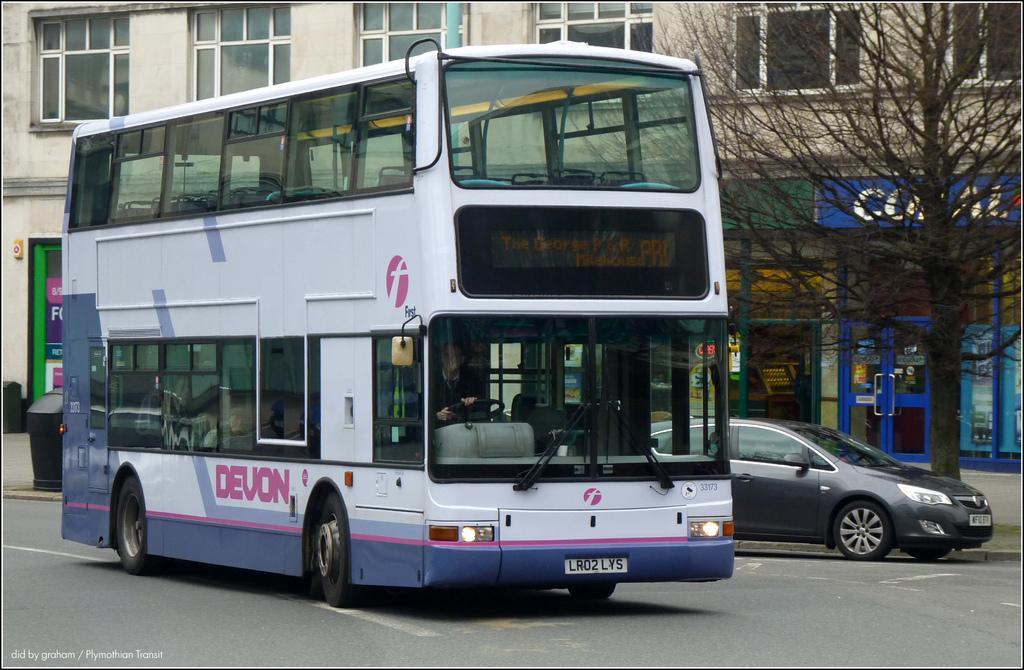In one or two sentences, can you explain what this image depicts? In the middle a bus is moving on the road, it is in white color, on the right side there is a tree. This is the building in the middle of an image. 